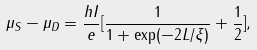<formula> <loc_0><loc_0><loc_500><loc_500>\mu _ { S } - \mu _ { D } = \frac { h I } { e } [ \frac { 1 } { 1 + \exp ( - 2 L / \xi ) } + \frac { 1 } { 2 } ] ,</formula> 